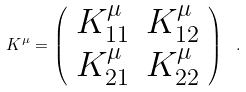<formula> <loc_0><loc_0><loc_500><loc_500>K ^ { \mu } = \left ( \begin{array} { c c } K ^ { \mu } _ { 1 1 } & K ^ { \mu } _ { 1 2 } \\ K ^ { \mu } _ { 2 1 } & K ^ { \mu } _ { 2 2 } \end{array} \right ) \ .</formula> 